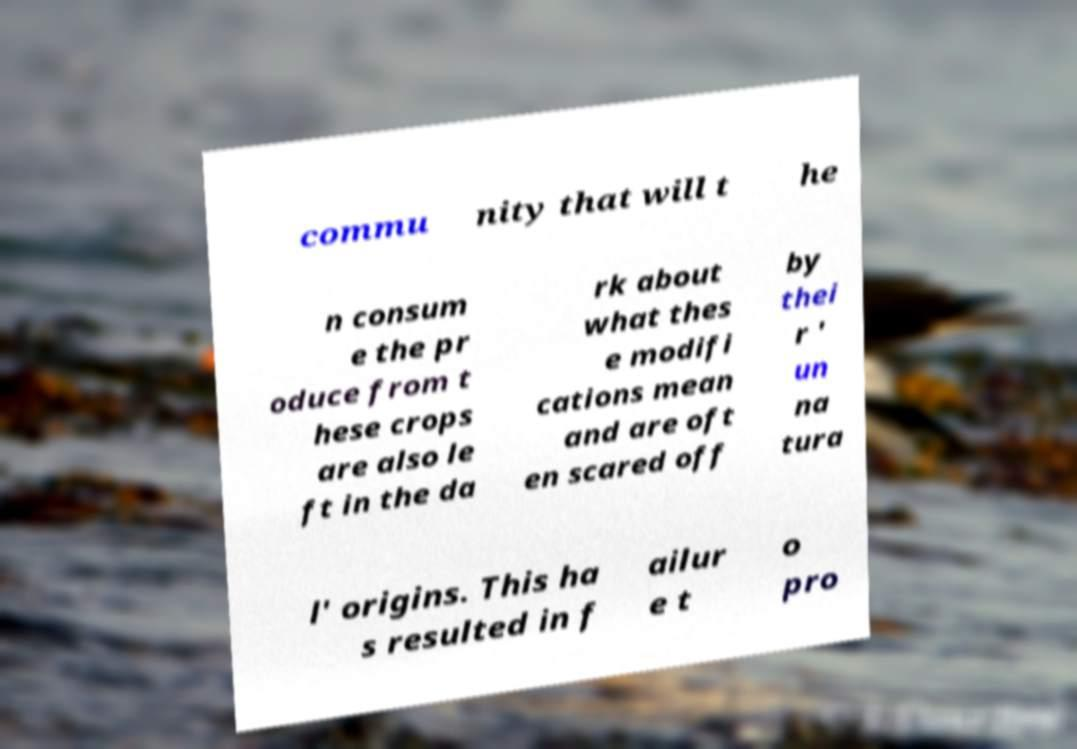Can you accurately transcribe the text from the provided image for me? commu nity that will t he n consum e the pr oduce from t hese crops are also le ft in the da rk about what thes e modifi cations mean and are oft en scared off by thei r ' un na tura l' origins. This ha s resulted in f ailur e t o pro 